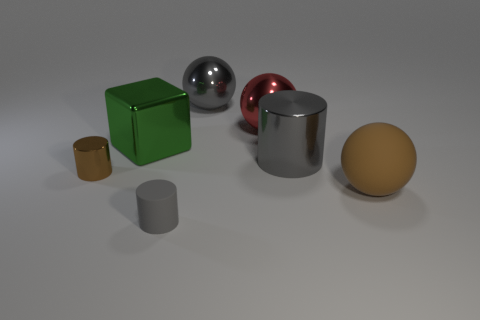There is a small brown object; is its shape the same as the gray metallic object that is on the left side of the red sphere?
Ensure brevity in your answer.  No. What number of objects are big metallic things or balls right of the gray ball?
Your answer should be compact. 5. There is a gray thing that is the same shape as the large brown matte thing; what is it made of?
Offer a terse response. Metal. There is a matte object on the left side of the large gray cylinder; is its shape the same as the red metallic thing?
Ensure brevity in your answer.  No. Is there any other thing that has the same size as the gray rubber thing?
Your answer should be very brief. Yes. Are there fewer large metal cylinders left of the tiny brown shiny cylinder than tiny objects that are on the right side of the big shiny cylinder?
Your response must be concise. No. What number of other objects are there of the same shape as the tiny rubber thing?
Provide a short and direct response. 2. What is the size of the gray rubber cylinder right of the brown thing that is left of the brown matte sphere to the right of the big cylinder?
Your response must be concise. Small. What number of brown things are either cylinders or small rubber cylinders?
Give a very brief answer. 1. The gray metal object behind the metallic cylinder to the right of the large green shiny object is what shape?
Give a very brief answer. Sphere. 